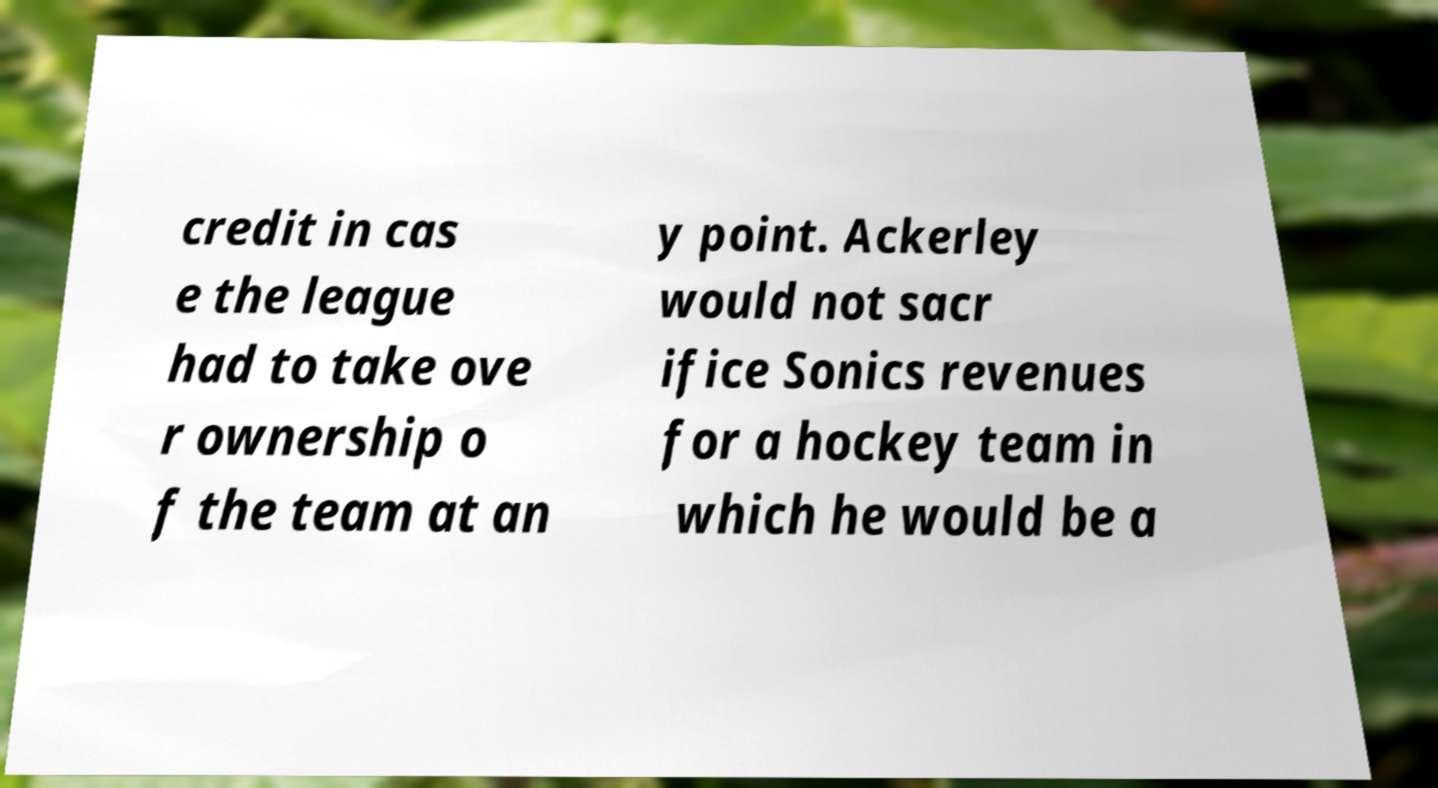What messages or text are displayed in this image? I need them in a readable, typed format. credit in cas e the league had to take ove r ownership o f the team at an y point. Ackerley would not sacr ifice Sonics revenues for a hockey team in which he would be a 